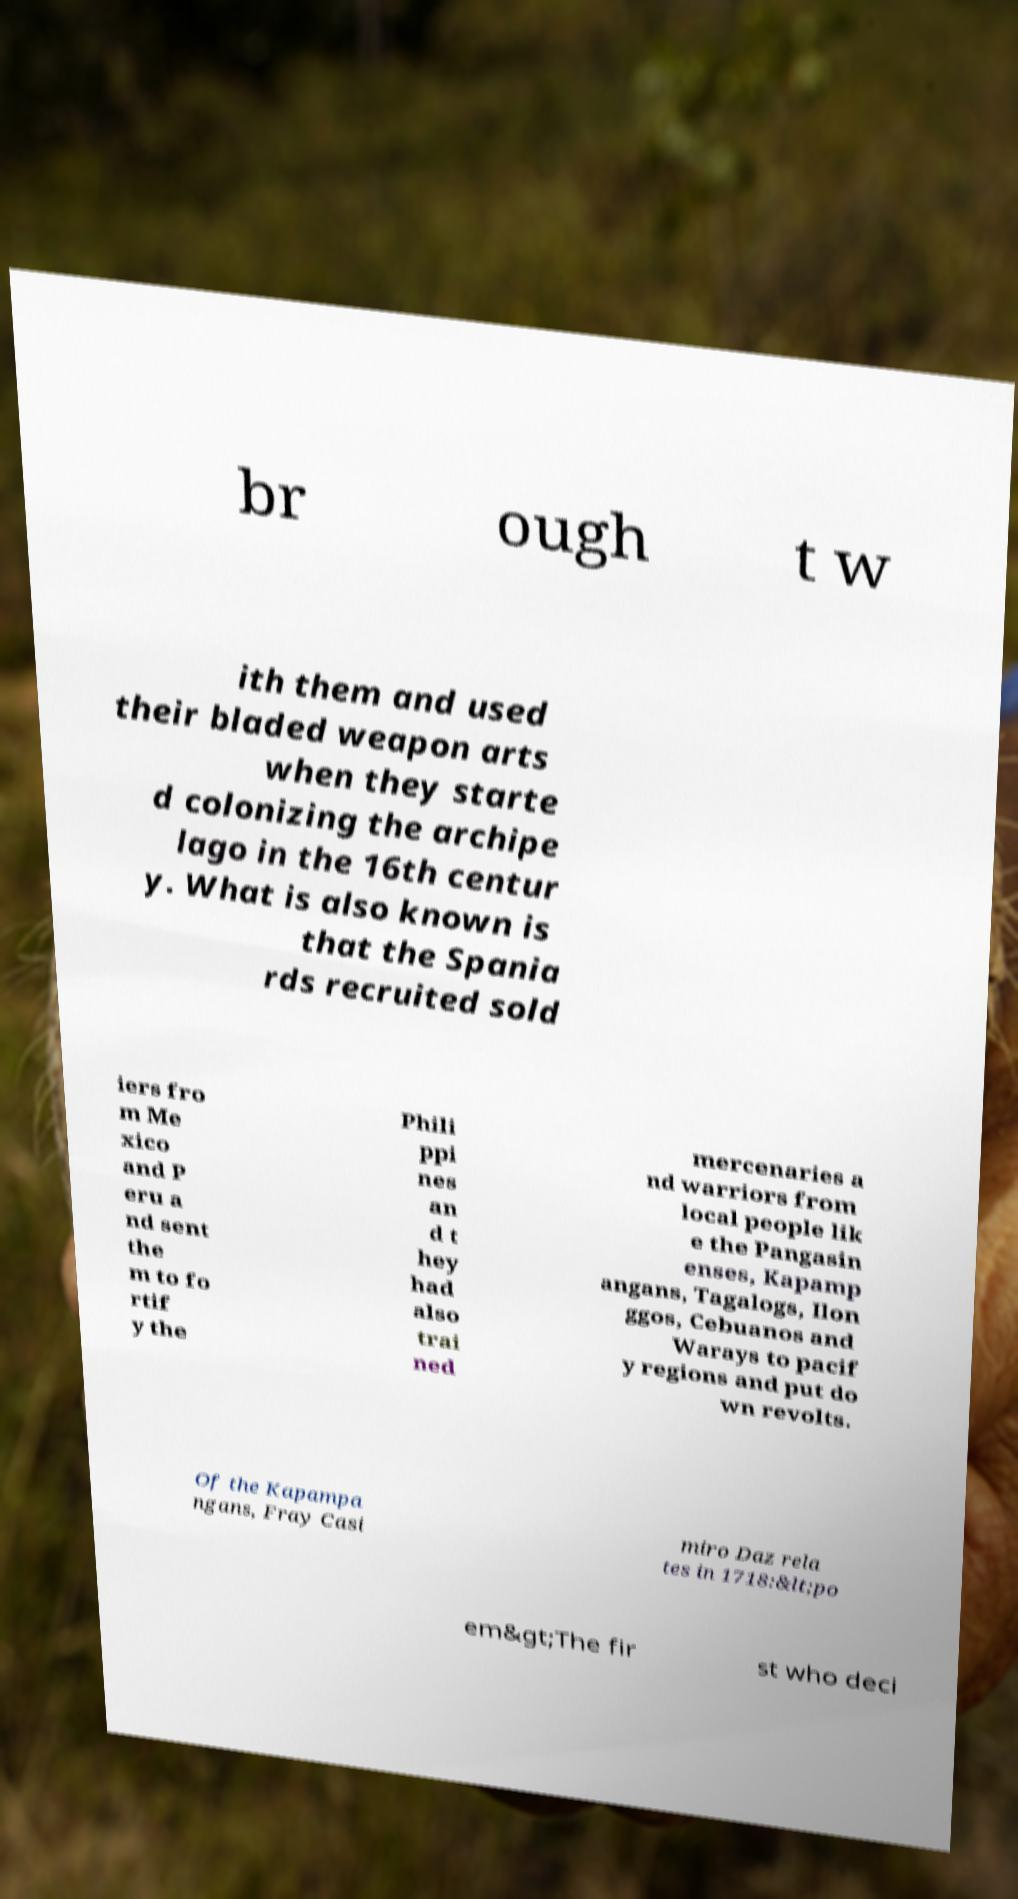Could you extract and type out the text from this image? br ough t w ith them and used their bladed weapon arts when they starte d colonizing the archipe lago in the 16th centur y. What is also known is that the Spania rds recruited sold iers fro m Me xico and P eru a nd sent the m to fo rtif y the Phili ppi nes an d t hey had also trai ned mercenaries a nd warriors from local people lik e the Pangasin enses, Kapamp angans, Tagalogs, Ilon ggos, Cebuanos and Warays to pacif y regions and put do wn revolts. Of the Kapampa ngans, Fray Casi miro Daz rela tes in 1718:&lt;po em&gt;The fir st who deci 